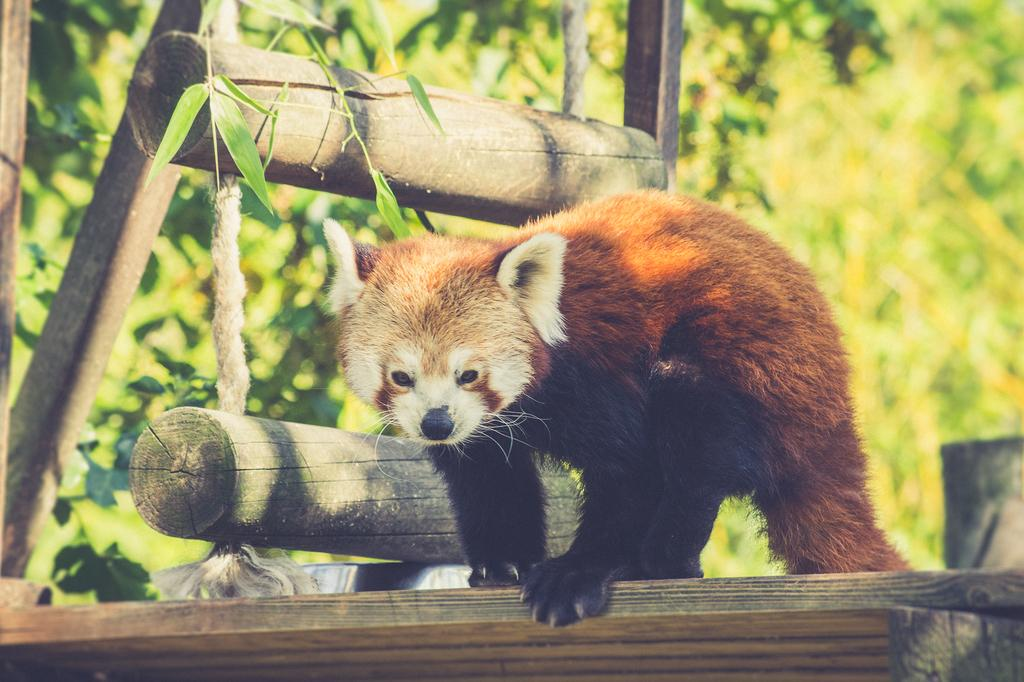What type of animal can be seen on the wood in the image? There is an animal on the wood in the image, but the specific type of animal cannot be determined from the provided facts. What is located in the background of the image? In the background of the image, there is a rope ladder, sticks, and trees. Can you describe the vegetation visible in the background? The vegetation visible in the background includes trees. What type of breakfast is the animal eating in the image? There is no breakfast present in the image, and the animal's actions are not described. How does the rope ladder affect the animal's throat in the image? There is no indication that the rope ladder has any effect on the animal's throat, as the animal's actions and the purpose of the rope ladder are not described in the provided facts. 